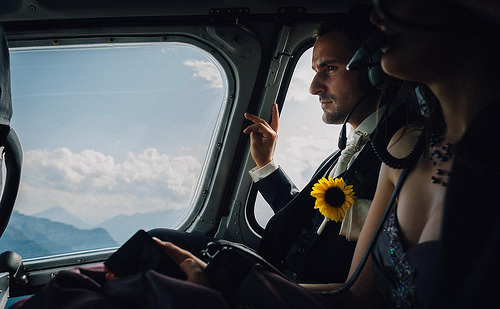<image>
Is there a sunflower to the right of the necklace? Yes. From this viewpoint, the sunflower is positioned to the right side relative to the necklace. 